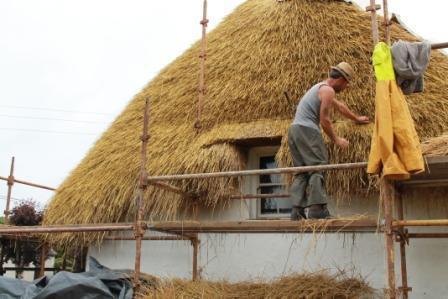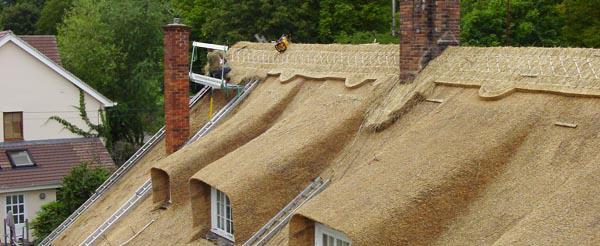The first image is the image on the left, the second image is the image on the right. Evaluate the accuracy of this statement regarding the images: "There are windows in the right image.". Is it true? Answer yes or no. Yes. 